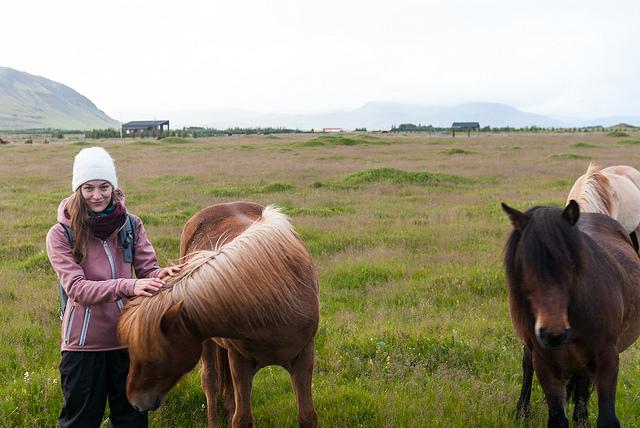How many horses are there?
Concise answer only. 3. What color is the girls coat?
Keep it brief. Pink. What is the woman wearing on her back?
Short answer required. Backpack. How many donkeys are in the photo?
Keep it brief. 0. What is the horse doing?
Answer briefly. Standing. 